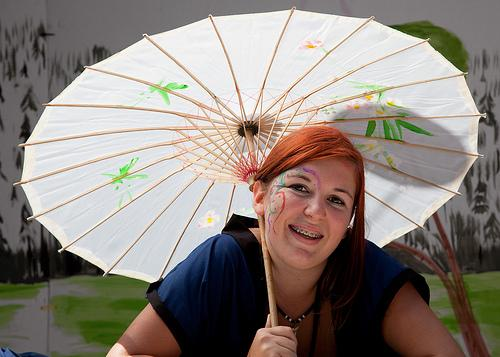What is the noteworthy accessory of the girl and what is its color? The girl has a white umbrella with painted flowers and green leaves on it. Provide a brief description of the central figure and their appearance. A girl with red hair, a blue shirt, and painted face is holding a white floral umbrella and smiling at the camera. Give a brief description of the girl's accessories and appearance. The girl has red hair, wears a blue shirt, holds a white umbrella with flowers, and has a painted face and a necklace. Write a sentence describing the background of the image. There's grass and a painting on a white wall in the background of the image. Write a sentence describing the girl's attire and a notable accessory she's wearing. The girl is wearing a blue shirt with black borders and a necklace with a black pendant around her neck. Explain the design and features of the umbrella the girl is holding. The umbrella is white with painted flowers, green foliage, and a wooden stick. Combine information about the girl's hair, her expression, and her outfit in one sentence. A smiling girl with red hair is wearing a blue shirt and has a painted face, as she holds a white umbrella. Describe the girl's hair color and an interesting aspect of her face. The girl has red hair and her face is adorned with colorful paint. 